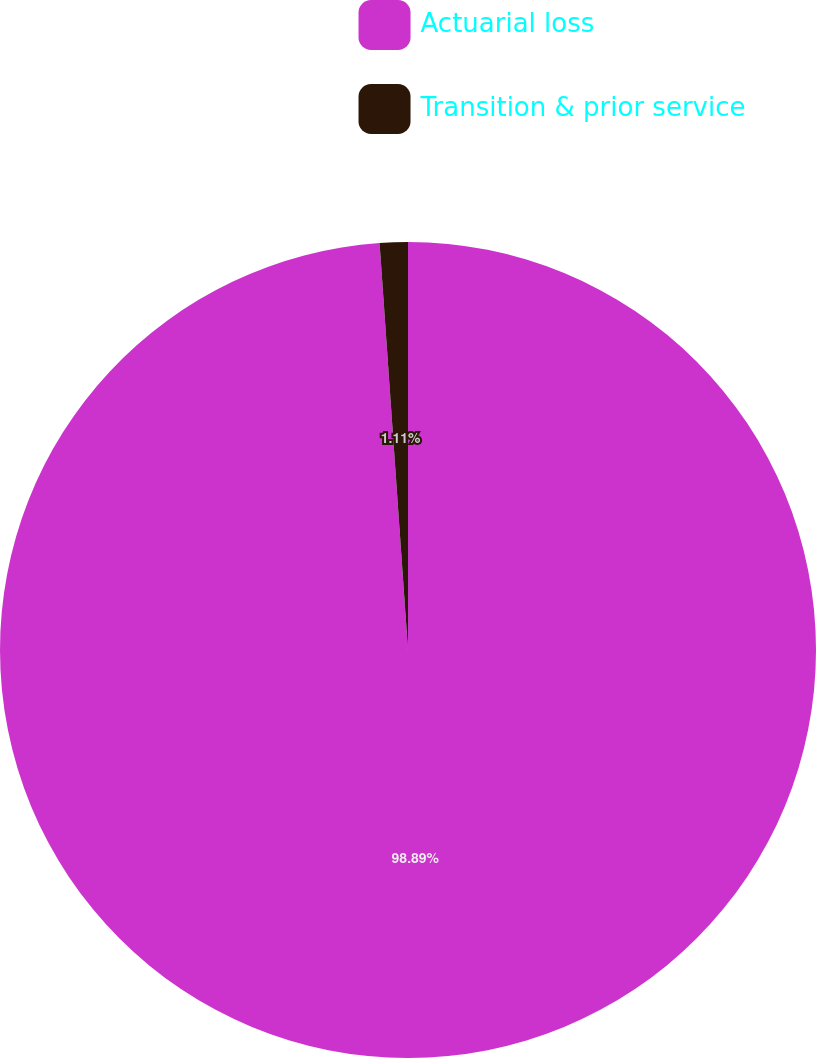Convert chart. <chart><loc_0><loc_0><loc_500><loc_500><pie_chart><fcel>Actuarial loss<fcel>Transition & prior service<nl><fcel>98.89%<fcel>1.11%<nl></chart> 